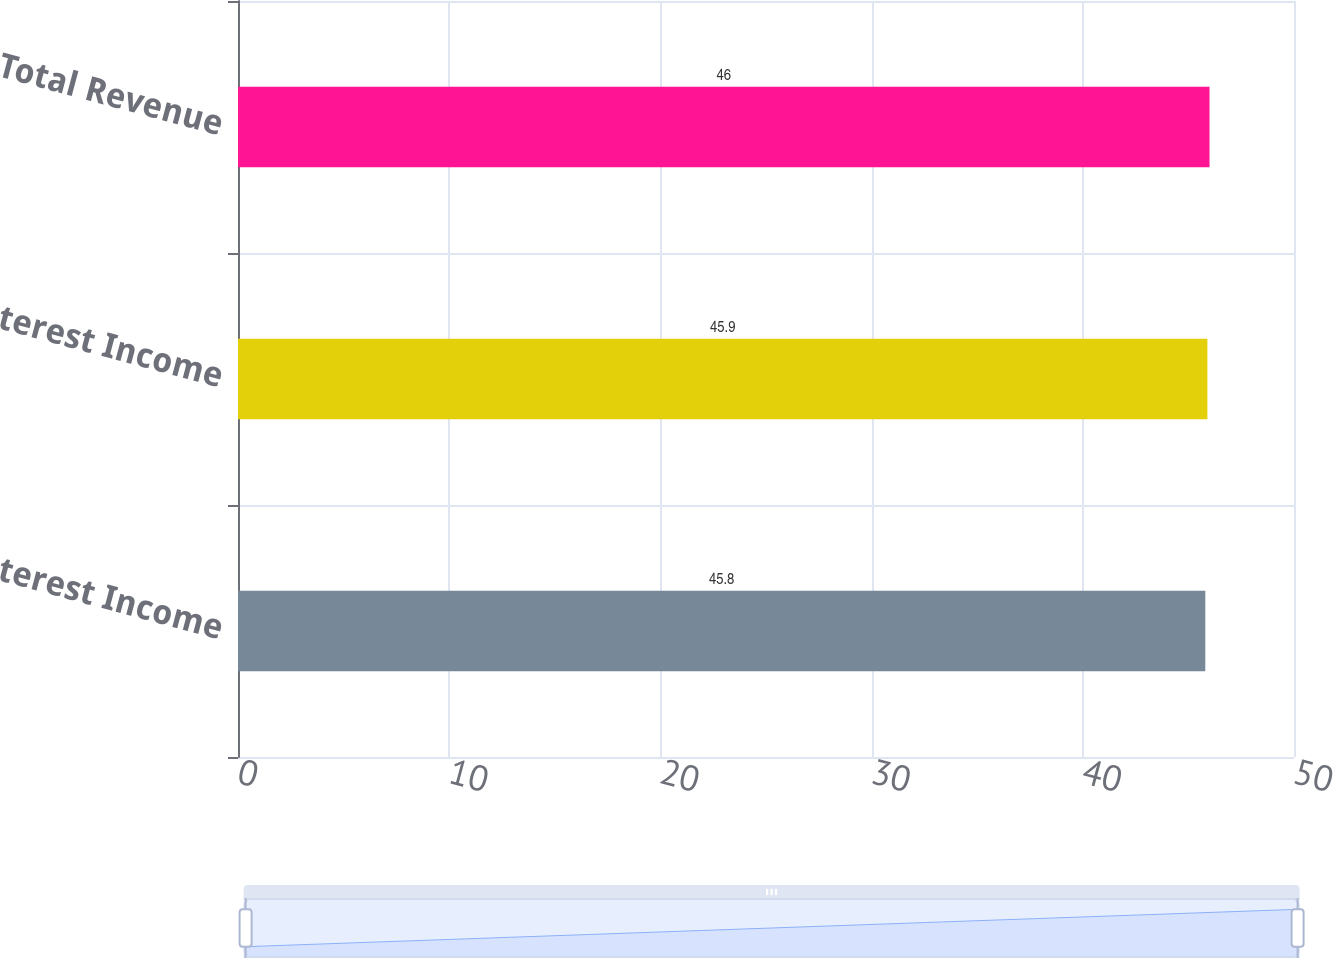Convert chart. <chart><loc_0><loc_0><loc_500><loc_500><bar_chart><fcel>Interest Income<fcel>Net Interest Income<fcel>Total Revenue<nl><fcel>45.8<fcel>45.9<fcel>46<nl></chart> 